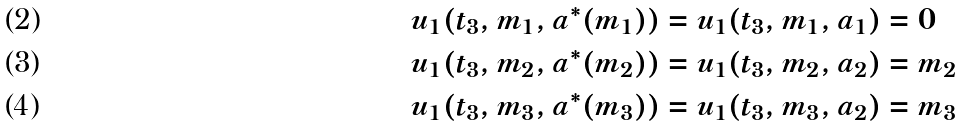<formula> <loc_0><loc_0><loc_500><loc_500>& u _ { 1 } ( t _ { 3 } , m _ { 1 } , a ^ { * } ( m _ { 1 } ) ) = u _ { 1 } ( t _ { 3 } , m _ { 1 } , a _ { 1 } ) = 0 \\ & u _ { 1 } ( t _ { 3 } , m _ { 2 } , a ^ { * } ( m _ { 2 } ) ) = u _ { 1 } ( t _ { 3 } , m _ { 2 } , a _ { 2 } ) = m _ { 2 } \\ & u _ { 1 } ( t _ { 3 } , m _ { 3 } , a ^ { * } ( m _ { 3 } ) ) = u _ { 1 } ( t _ { 3 } , m _ { 3 } , a _ { 2 } ) = m _ { 3 }</formula> 